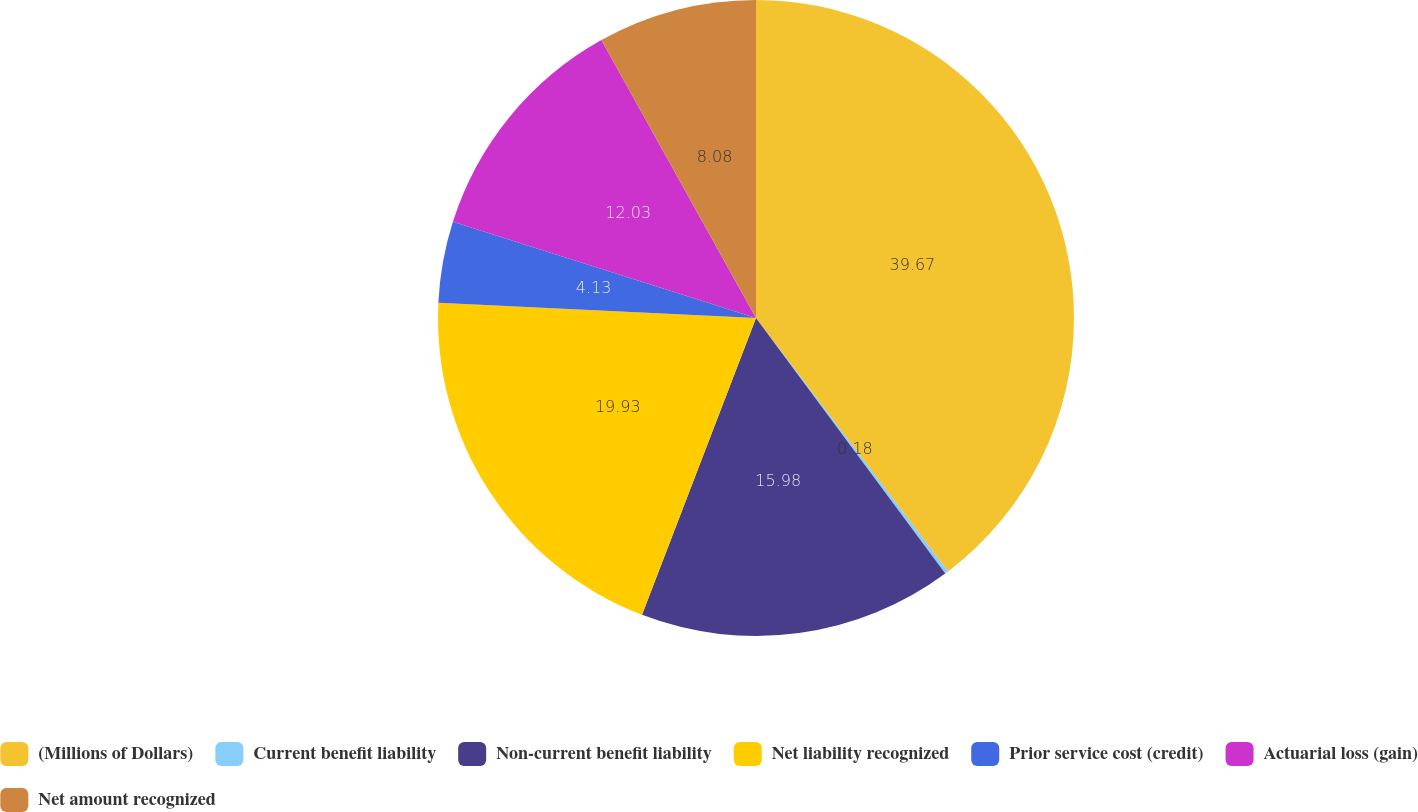Convert chart to OTSL. <chart><loc_0><loc_0><loc_500><loc_500><pie_chart><fcel>(Millions of Dollars)<fcel>Current benefit liability<fcel>Non-current benefit liability<fcel>Net liability recognized<fcel>Prior service cost (credit)<fcel>Actuarial loss (gain)<fcel>Net amount recognized<nl><fcel>39.68%<fcel>0.18%<fcel>15.98%<fcel>19.93%<fcel>4.13%<fcel>12.03%<fcel>8.08%<nl></chart> 